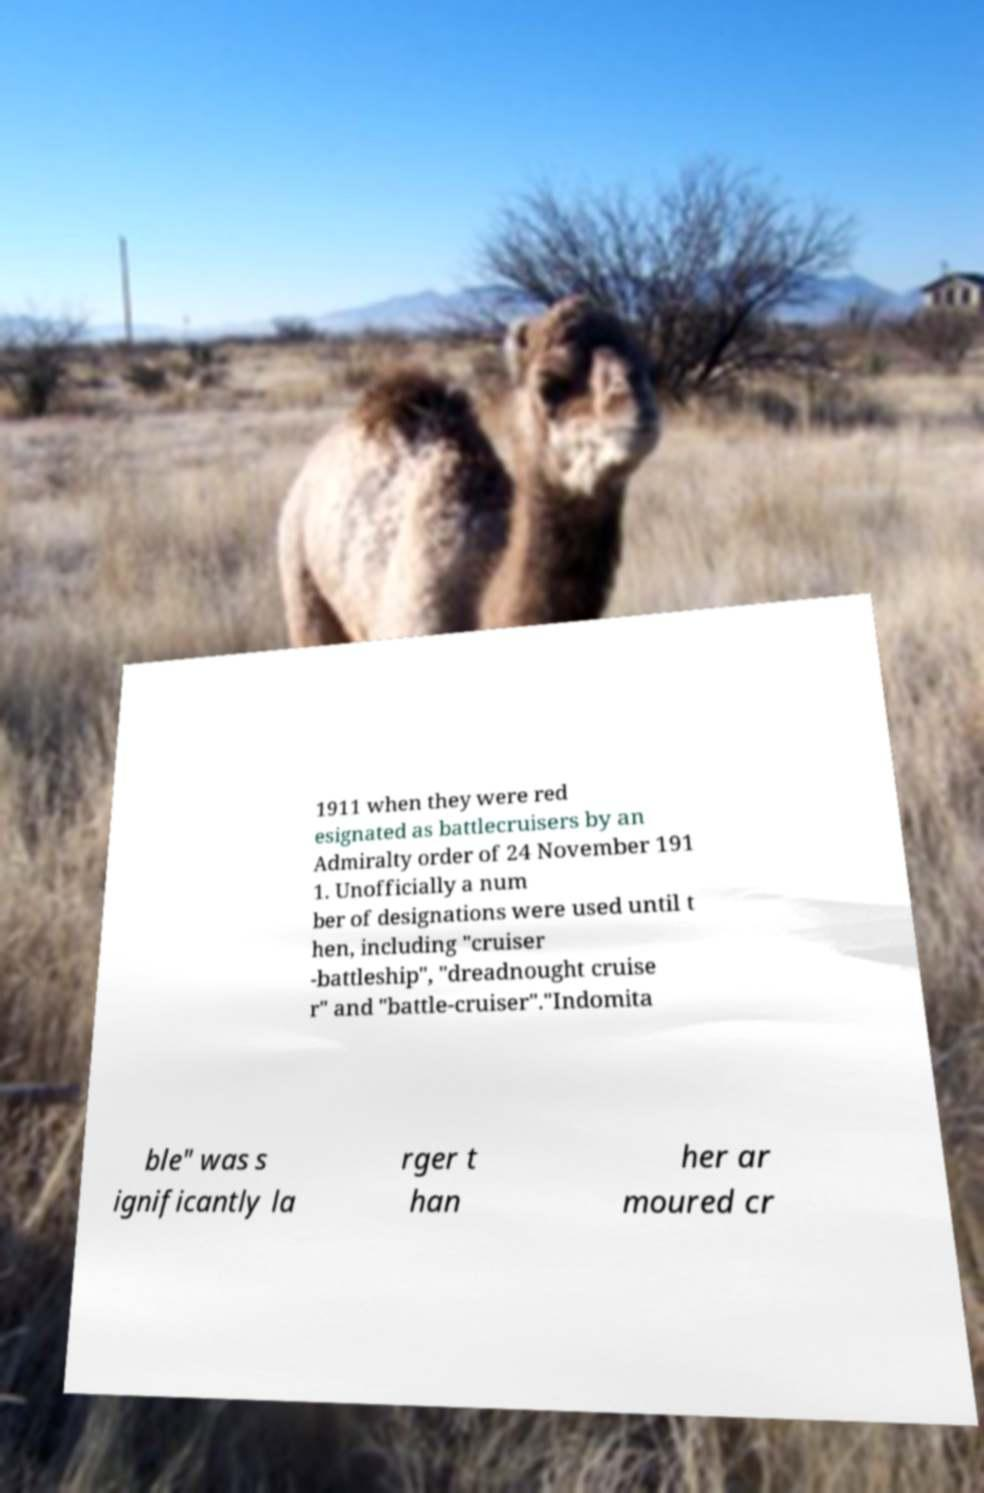Can you read and provide the text displayed in the image?This photo seems to have some interesting text. Can you extract and type it out for me? 1911 when they were red esignated as battlecruisers by an Admiralty order of 24 November 191 1. Unofficially a num ber of designations were used until t hen, including "cruiser -battleship", "dreadnought cruise r" and "battle-cruiser"."Indomita ble" was s ignificantly la rger t han her ar moured cr 